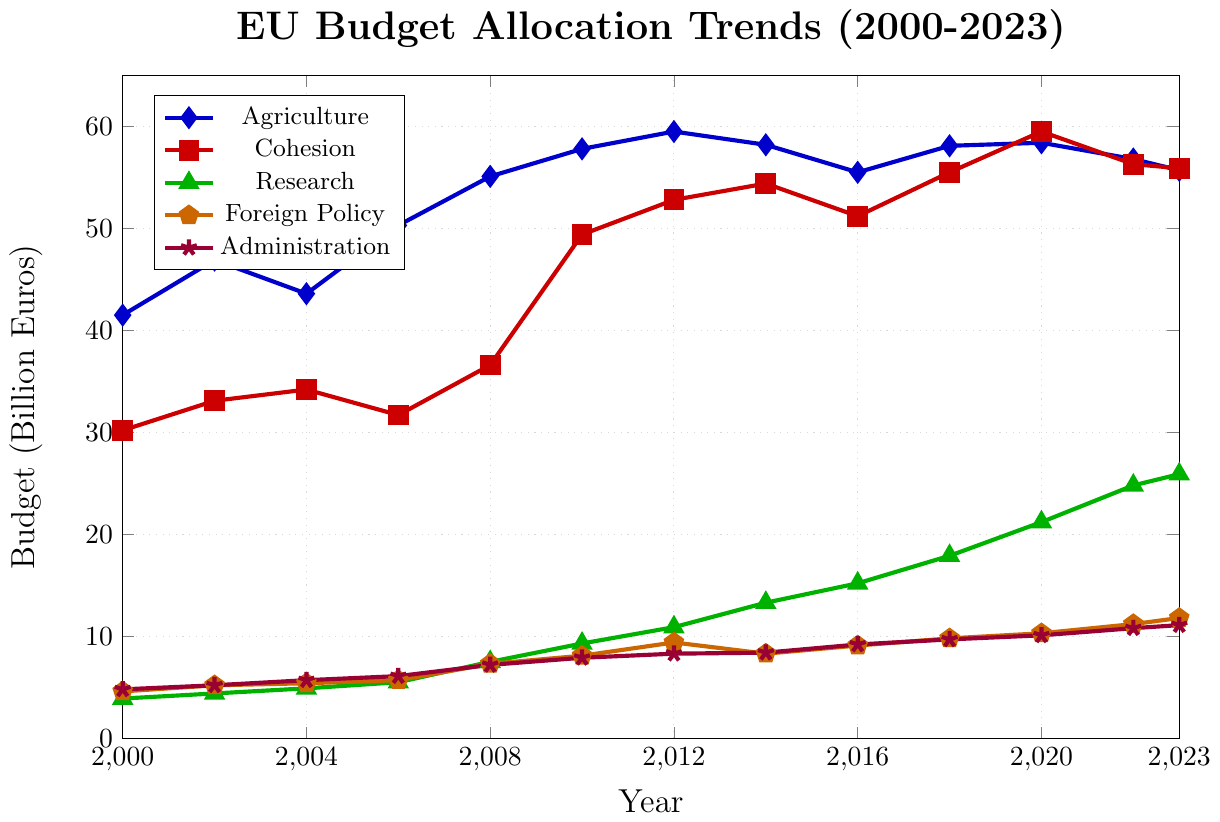What's the peak budget allocation for Agriculture and in which year did it occur? To find the peak budget allocation for Agriculture, look for the highest point on its line (blue with diamonds) on the chart. The peak value is 59.5 billion euros, which occurs in 2012.
Answer: 59.5 billion euros in 2012 Which policy area had the most significant increase in budget allocation from 2000 to 2023? Calculate the difference between the budget allocation in 2023 and 2000 for each policy area. Research increased from 3.9 billion euros to 25.9 billion euros, giving an increase of 22 billion euros—the highest among the categories.
Answer: Research Between 2000 and 2023, which policy area's budget shows the least volatility in terms of visual slope and fluctuations? Examine the smoothness and consistency of each line on the chart. The Administration budget line (purple with stars) has the least steep and consistent gradient without much sharp increase or decrease.
Answer: Administration In which year do Agriculture and Cohesion budgets converge closest together? Identify where the lines for Agriculture and Cohesion come closest together. In 2016, Agriculture is 55.5 and Cohesion is 51.2, differing by 4.3 billion euros—a smaller gap compared to other years around it.
Answer: 2016 How did the budget allocation for Foreign Policy change between 2014 and 2023? Check the Foreign Policy line (orange with pentagons) for the values at 2014 (8.3 billion euros) and 2023 (11.8 billion euros). The change is 11.8 - 8.3 = 3.5 billion euros.
Answer: Increased by 3.5 billion euros Which year saw the highest total budget allocation across all policy areas combined? Sum the budget allocations for all policy areas for each year and compare. 2020 had 58.4 (Agriculture) + 59.5 (Cohesion) + 21.2 (Research) + 10.3 (Foreign Policy) + 10.1 (Administration) = 159.5 billion euros—the highest total.
Answer: 2020 What was the budget difference between Research and Cohesion in 2023? For 2023, subtract the Research budget (25.9 billion euros) from the Cohesion budget (55.9 billion euros). The difference is 55.9 - 25.9 = 30 billion euros.
Answer: 30 billion euros Between 2000 and 2023, which policy area showed the most consistent uptrend without any decreases? Visually trace the lines and note any declines. Research (green with triangles) shows a consistent uptrend without any decreases over the years.
Answer: Research 